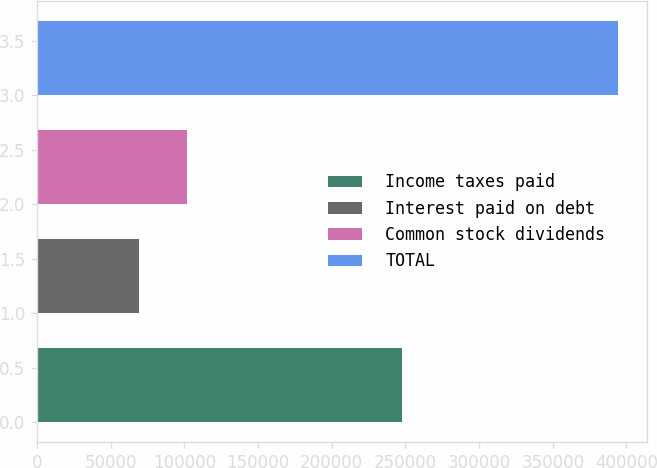Convert chart. <chart><loc_0><loc_0><loc_500><loc_500><bar_chart><fcel>Income taxes paid<fcel>Interest paid on debt<fcel>Common stock dividends<fcel>TOTAL<nl><fcel>247771<fcel>68875<fcel>101402<fcel>394141<nl></chart> 